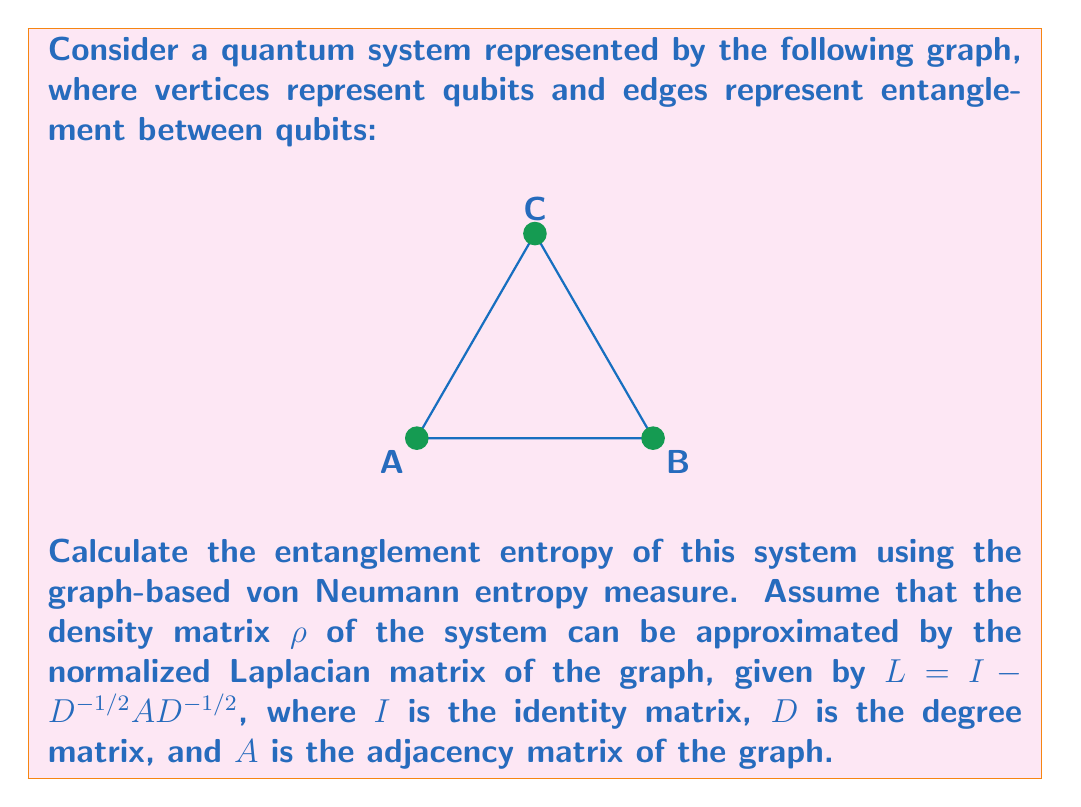Can you solve this math problem? To solve this problem, we'll follow these steps:

1) First, we need to construct the adjacency matrix $A$ and degree matrix $D$ for the given graph.

2) Then, we'll calculate the normalized Laplacian matrix $L$.

3) We'll find the eigenvalues of $L$.

4) Finally, we'll use these eigenvalues to calculate the von Neumann entropy.

Step 1: Constructing matrices $A$ and $D$

The adjacency matrix $A$ for this graph is:

$$A = \begin{pmatrix}
0 & 1 & 1 \\
1 & 0 & 1 \\
1 & 1 & 0
\end{pmatrix}$$

The degree matrix $D$ is:

$$D = \begin{pmatrix}
2 & 0 & 0 \\
0 & 2 & 0 \\
0 & 0 & 2
\end{pmatrix}$$

Step 2: Calculating the normalized Laplacian matrix $L$

$$L = I - D^{-1/2}AD^{-1/2}$$

$$D^{-1/2} = \begin{pmatrix}
1/\sqrt{2} & 0 & 0 \\
0 & 1/\sqrt{2} & 0 \\
0 & 0 & 1/\sqrt{2}
\end{pmatrix}$$

$$L = \begin{pmatrix}
1 & 0 & 0 \\
0 & 1 & 0 \\
0 & 0 & 1
\end{pmatrix} - \begin{pmatrix}
1/\sqrt{2} & 0 & 0 \\
0 & 1/\sqrt{2} & 0 \\
0 & 0 & 1/\sqrt{2}
\end{pmatrix}\begin{pmatrix}
0 & 1 & 1 \\
1 & 0 & 1 \\
1 & 1 & 0
\end{pmatrix}\begin{pmatrix}
1/\sqrt{2} & 0 & 0 \\
0 & 1/\sqrt{2} & 0 \\
0 & 0 & 1/\sqrt{2}
\end{pmatrix}$$

$$L = \begin{pmatrix}
1 & 0 & 0 \\
0 & 1 & 0 \\
0 & 0 & 1
\end{pmatrix} - \begin{pmatrix}
0 & 1/2 & 1/2 \\
1/2 & 0 & 1/2 \\
1/2 & 1/2 & 0
\end{pmatrix} = \begin{pmatrix}
1 & -1/2 & -1/2 \\
-1/2 & 1 & -1/2 \\
-1/2 & -1/2 & 1
\end{pmatrix}$$

Step 3: Finding eigenvalues of $L$

The characteristic equation is:

$$(1-\lambda)^3 - 3(1-\lambda)(-1/2)^2 = 0$$

$$(1-\lambda)^3 - 3/4(1-\lambda) = 0$$

$$(1-\lambda)((1-\lambda)^2 - 3/4) = 0$$

Solving this, we get eigenvalues: $\lambda_1 = 0$, $\lambda_2 = 3/2$, $\lambda_3 = 3/2$

Step 4: Calculating von Neumann entropy

The von Neumann entropy is given by:

$$S = -\sum_i \lambda_i \log_2 \lambda_i$$

where we only consider non-zero eigenvalues.

$$S = -2 \cdot (3/2) \log_2 (3/2) = -3 \log_2 (3/2) \approx 0.918$$
Answer: $S \approx 0.918$ 